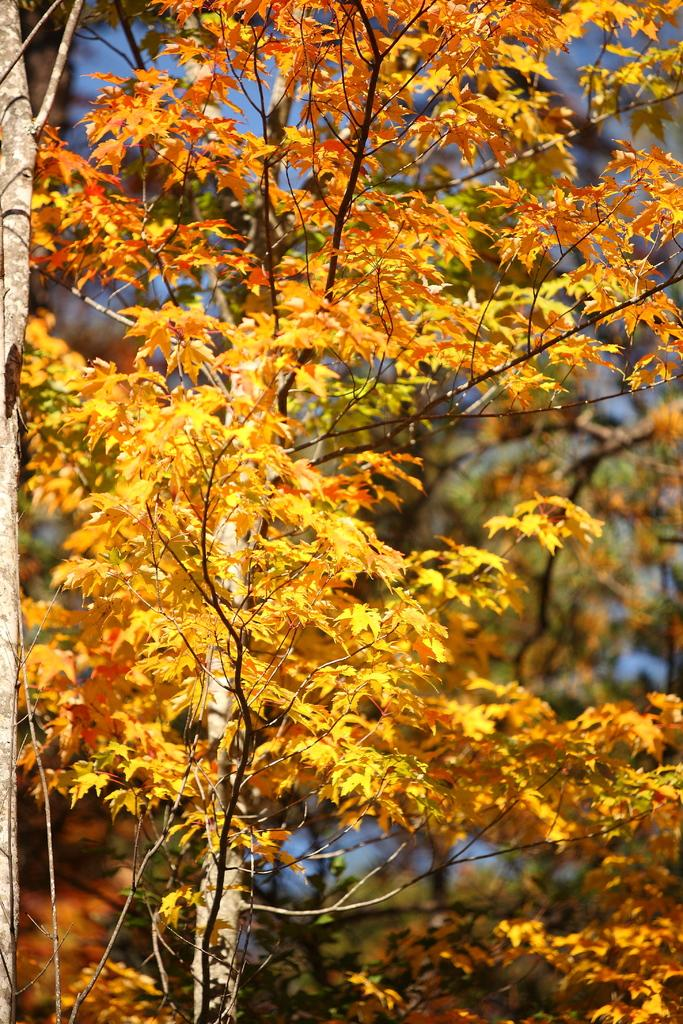What type of plant is present in the image? There is a plant with yellow leaves in the image. What can be seen behind the plant in the image? There are many trees behind the plant in the image. What type of rice is being cooked in the image? There is no rice present in the image; it features a plant with yellow leaves and many trees in the background. 